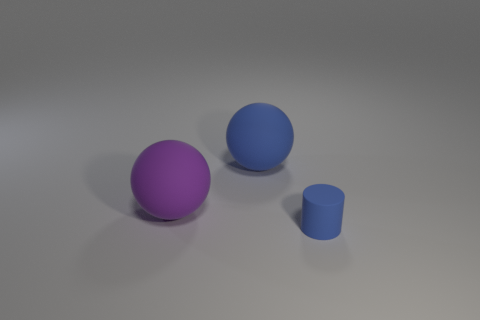Add 3 small brown metal blocks. How many objects exist? 6 Subtract all cylinders. How many objects are left? 2 Subtract all tiny blue cylinders. Subtract all large blue matte spheres. How many objects are left? 1 Add 3 small blue things. How many small blue things are left? 4 Add 2 large red cylinders. How many large red cylinders exist? 2 Subtract 0 red cubes. How many objects are left? 3 